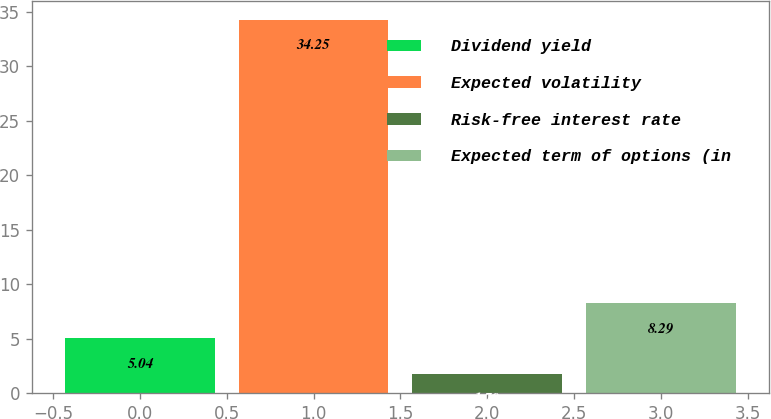Convert chart. <chart><loc_0><loc_0><loc_500><loc_500><bar_chart><fcel>Dividend yield<fcel>Expected volatility<fcel>Risk-free interest rate<fcel>Expected term of options (in<nl><fcel>5.04<fcel>34.25<fcel>1.79<fcel>8.29<nl></chart> 